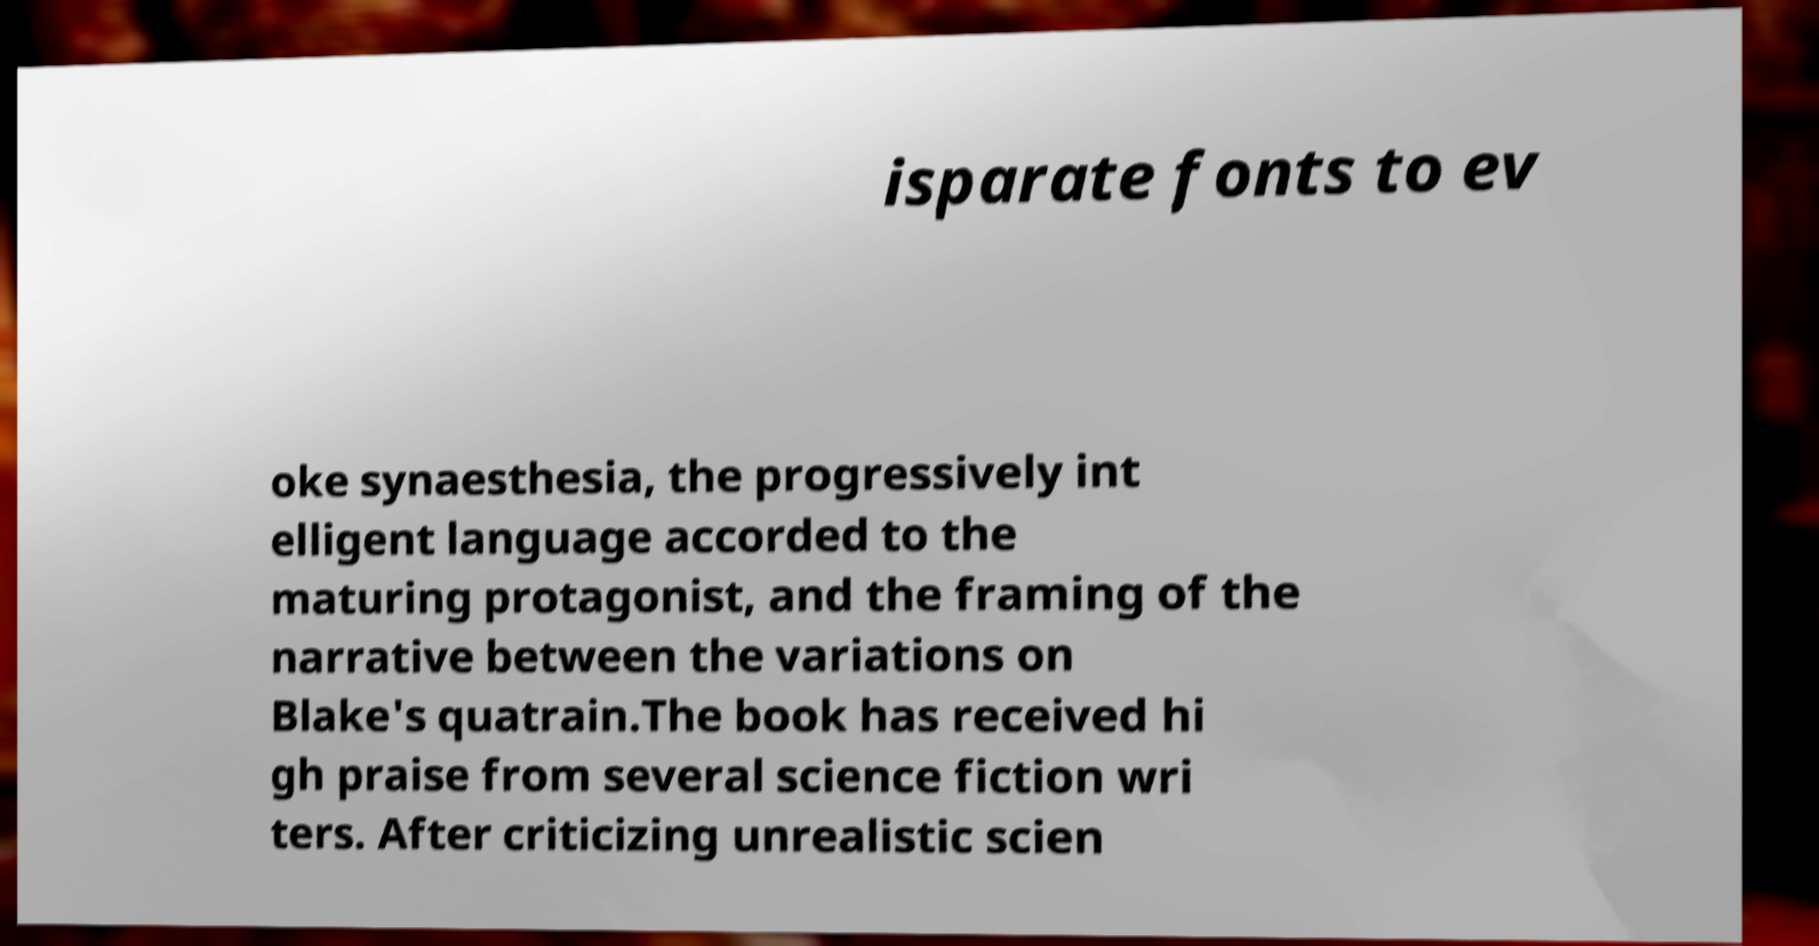I need the written content from this picture converted into text. Can you do that? isparate fonts to ev oke synaesthesia, the progressively int elligent language accorded to the maturing protagonist, and the framing of the narrative between the variations on Blake's quatrain.The book has received hi gh praise from several science fiction wri ters. After criticizing unrealistic scien 